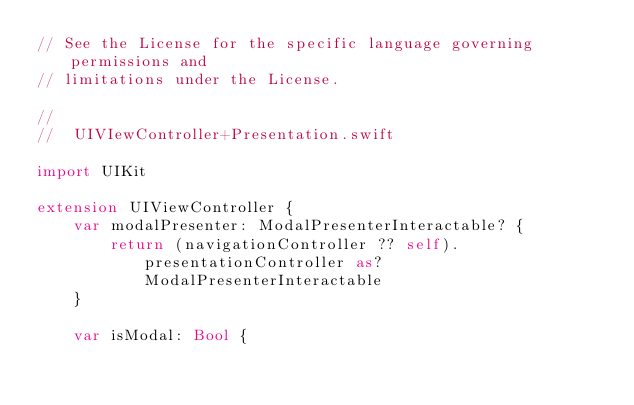Convert code to text. <code><loc_0><loc_0><loc_500><loc_500><_Swift_>// See the License for the specific language governing permissions and
// limitations under the License.

//
//  UIVIewController+Presentation.swift

import UIKit

extension UIViewController {
    var modalPresenter: ModalPresenterInteractable? {
        return (navigationController ?? self).presentationController as? ModalPresenterInteractable
    }
    
    var isModal: Bool {</code> 